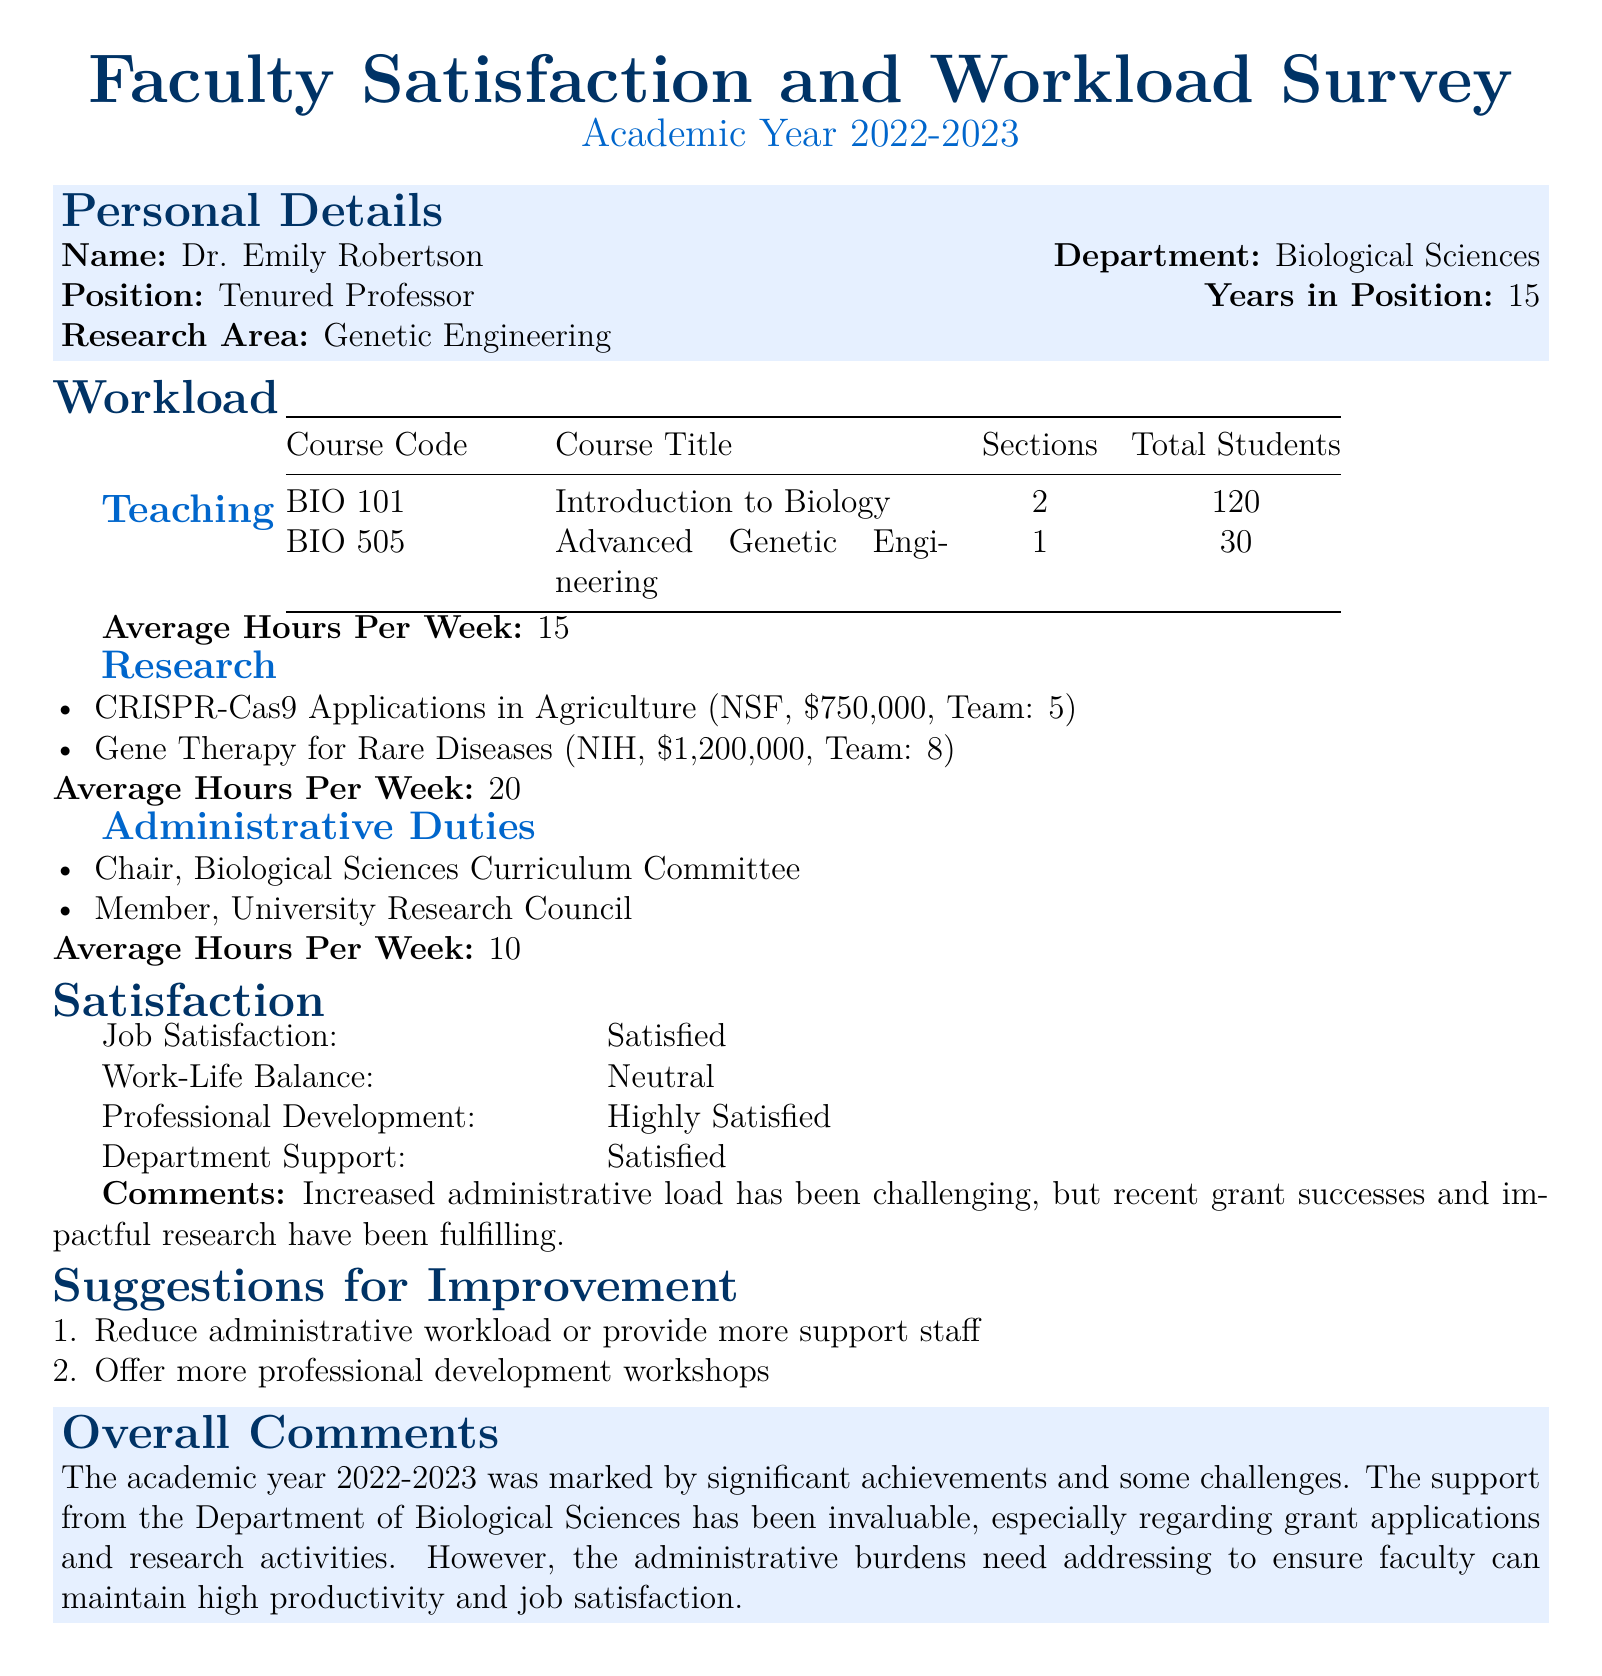What is Dr. Emily Robertson's position? The position of Dr. Emily Robertson is stated as "Tenured Professor."
Answer: Tenured Professor How many students are enrolled in BIO 101? The number of students enrolled in BIO 101 is provided in the table under "Total Students."
Answer: 120 What are the average hours per week spent on research? The average hours per week spent on research is noted in the section labeled "Research."
Answer: 20 What is Dr. Robertson's research area? The research area is specified in the personal details section of the document.
Answer: Genetic Engineering What is the total amount of funding for the Gene Therapy for Rare Diseases project? The funding amount is indicated next to the project in the research section, specifically under that title.
Answer: 1,200,000 What was Dr. Robertson's level of satisfaction with department support? The level of satisfaction with department support is listed in the satisfaction table.
Answer: Satisfied What is one suggestion for improvement made by Dr. Robertson? Suggestions for improvement are listed in the corresponding section, and one suggestion is highlighted.
Answer: Reduce administrative workload or provide more support staff How many years has Dr. Robertson been in her position? The number of years in the position is explicitly mentioned in the personal details section.
Answer: 15 What is Dr. Robertson's comment regarding the academic year 2022-2023? The overall comments section includes Dr. Robertson's remarks on her experiences during the academic year.
Answer: The academic year 2022-2023 was marked by significant achievements and some challenges 